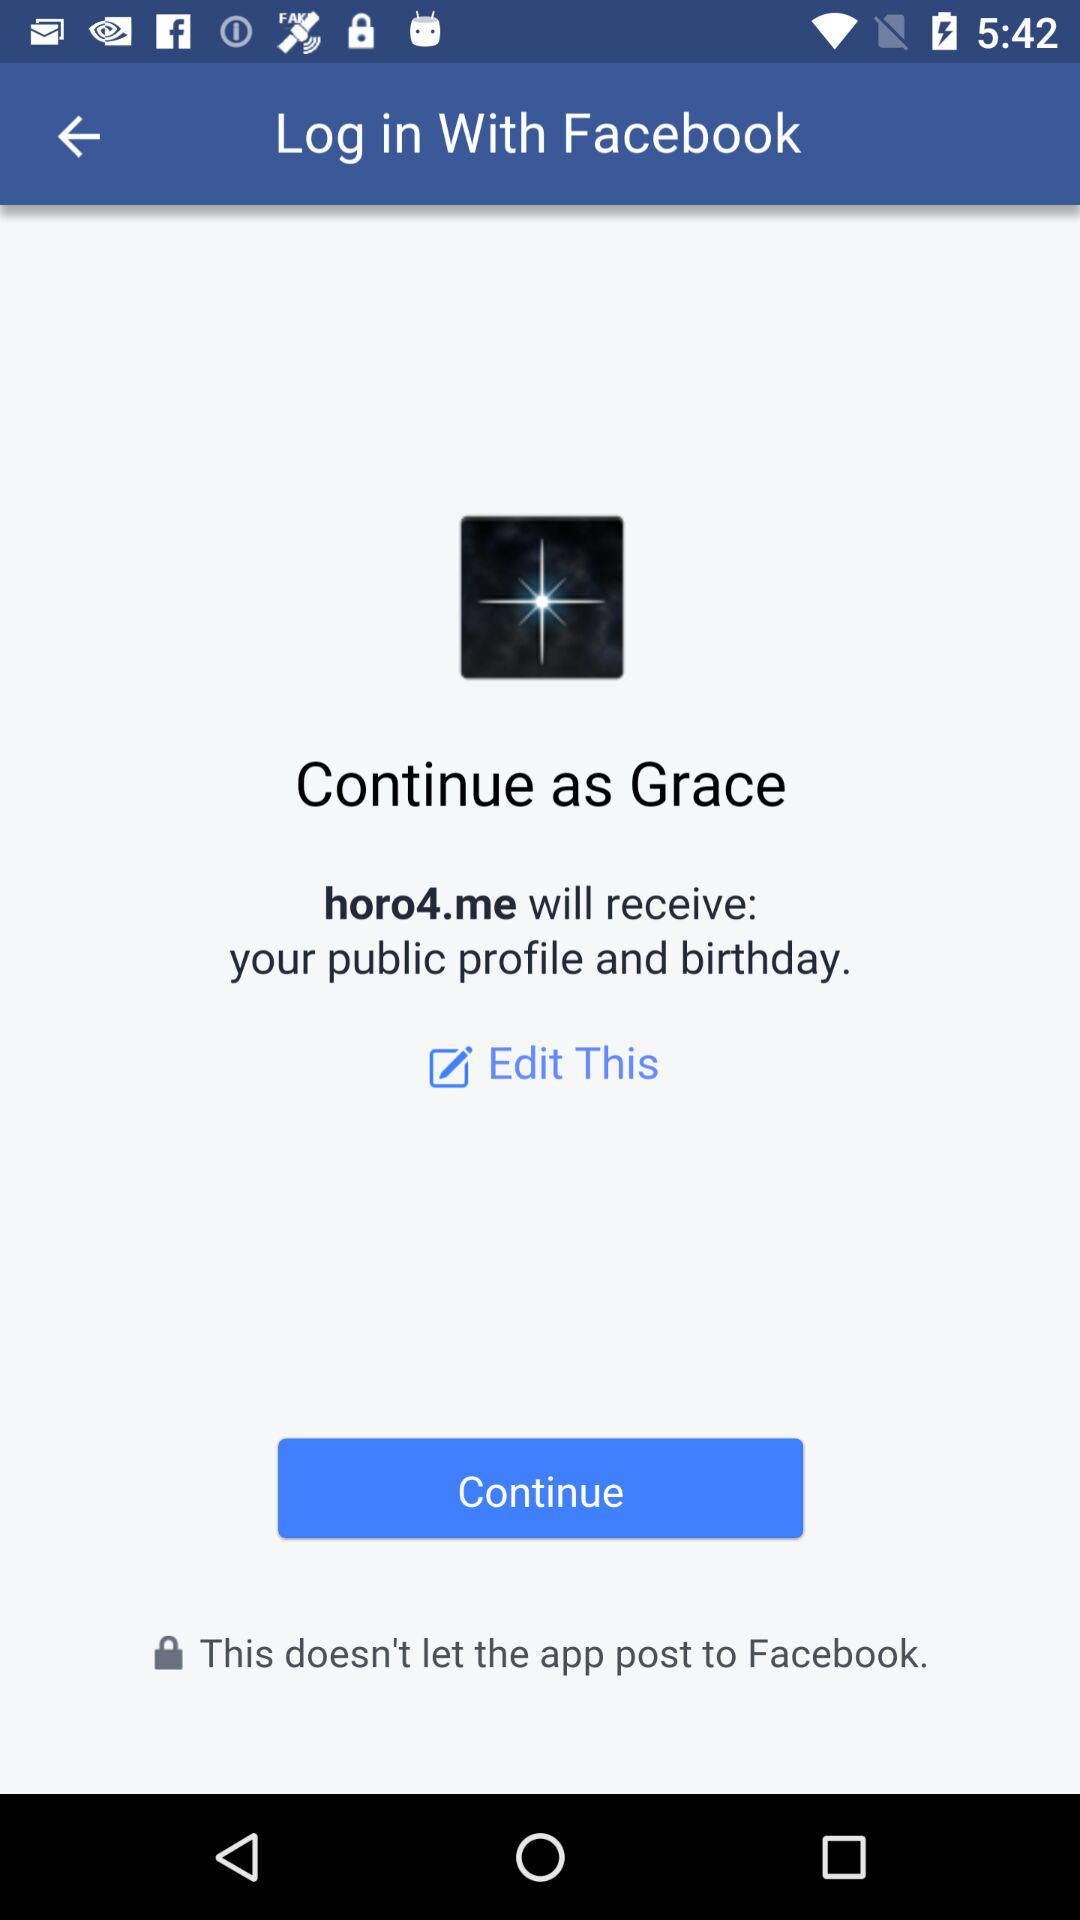What is the user name? The user name is Grace. 